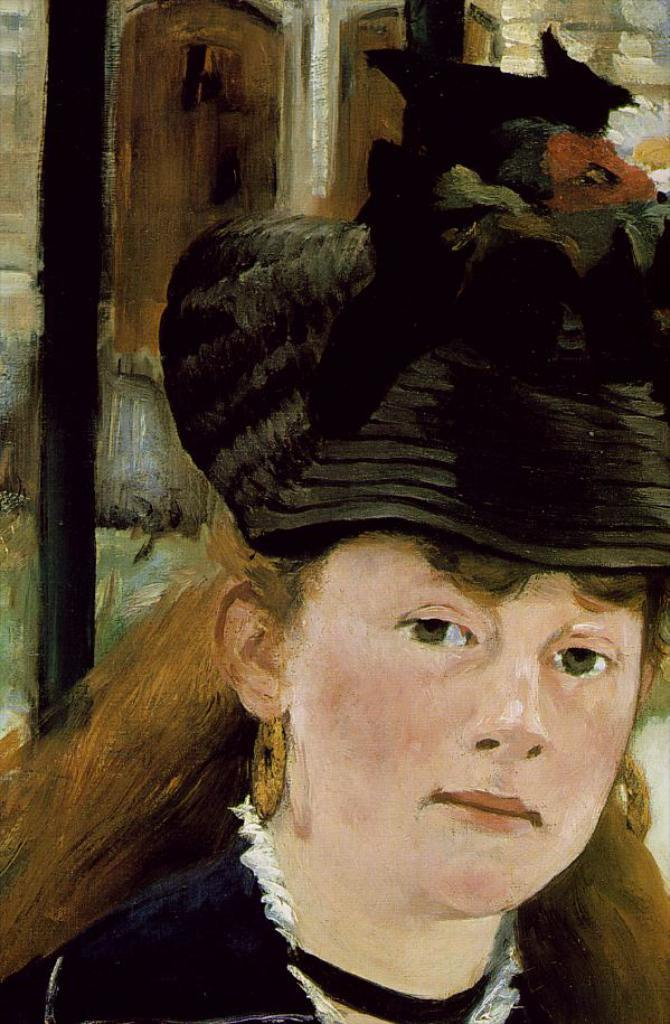What type of artwork is shown in the image? The image is a painting. Who or what is the main subject of the painting? The painting depicts a lady. What accessories is the lady wearing in the painting? The lady is wearing earrings and a hat. What decorative elements are present on the lady's hat? There are flowers on the hat. What time of day is depicted in the painting? The provided facts do not mention the time of day, so it cannot be determined from the image. 